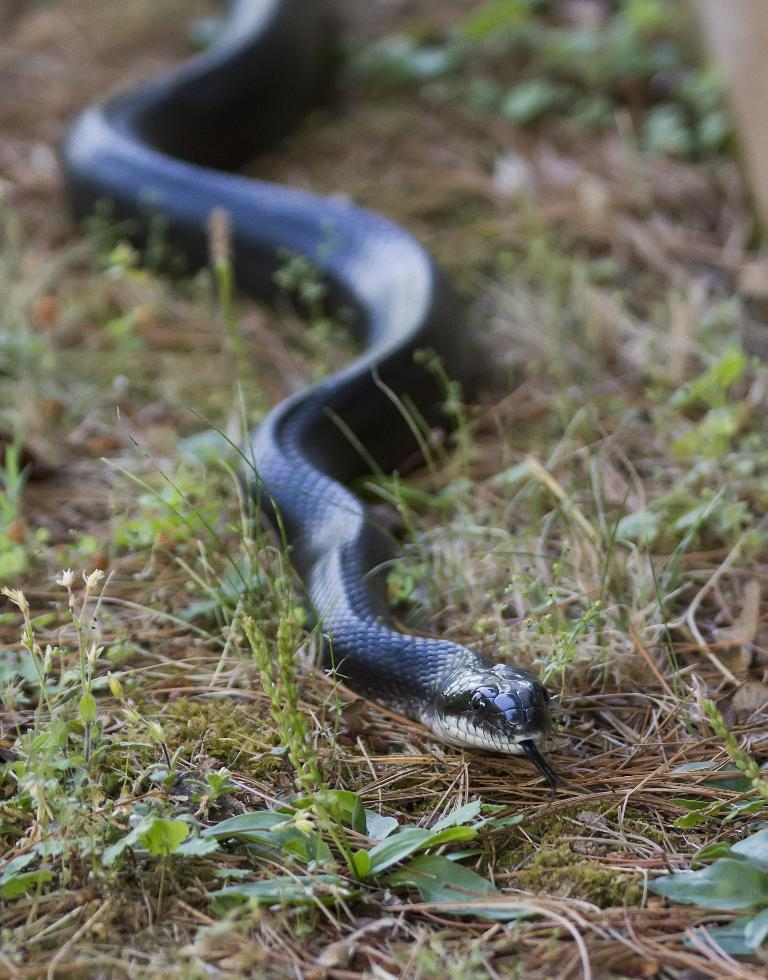What type of animal is in the image? There is a black color snake in the image. What is the snake doing in the image? The snake is crawling on the grass. What type of terrain is visible in the image? There is grass visible in the image. Is there any issue with the image's clarity? Yes, the image is slightly blurred in the mentioned part. What type of planes can be seen flying in the image? There are no planes visible in the image; it features a black color snake crawling on the grass. Is there a baseball game happening in the image? There is no baseball game or any reference to baseball in the image. 